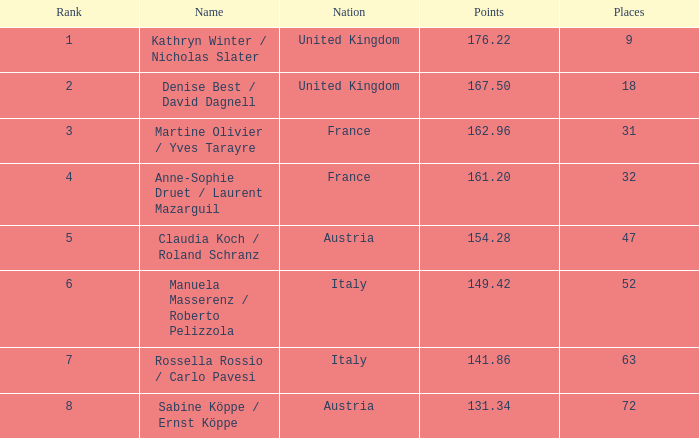Who has points exceeding 16 Kathryn Winter / Nicholas Slater. 